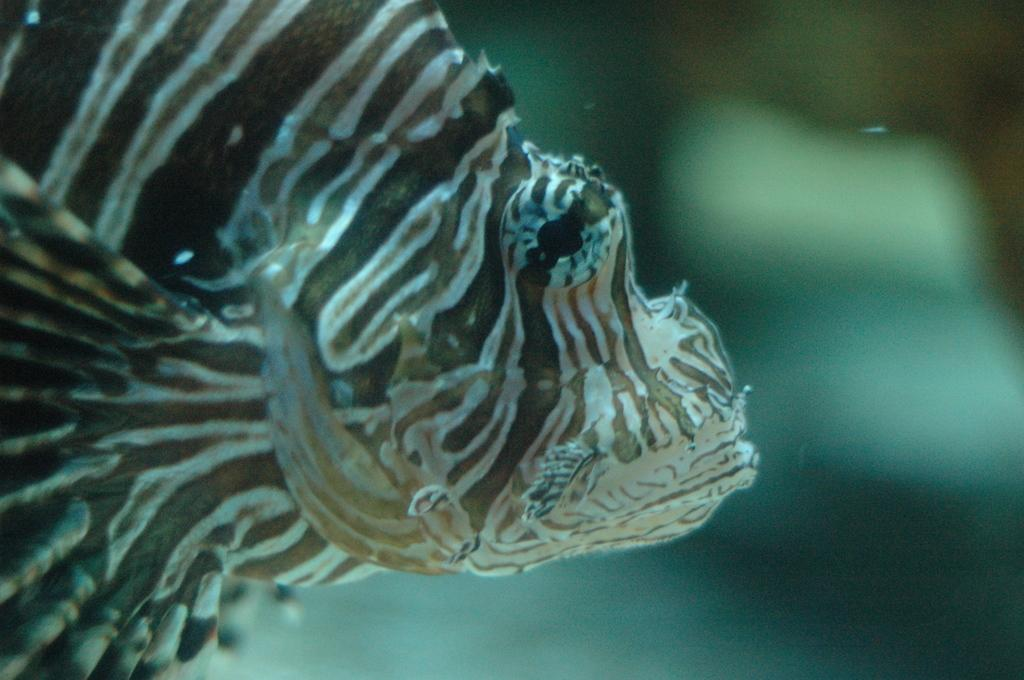What type of animal is in the image? There is a fish in the image. Where is the fish located? The fish is in the water. What color is the moon in the image? There is no moon present in the image. What type of paint is used to color the fish in the image? The image is not a painting, so there is no paint used to color the fish. 